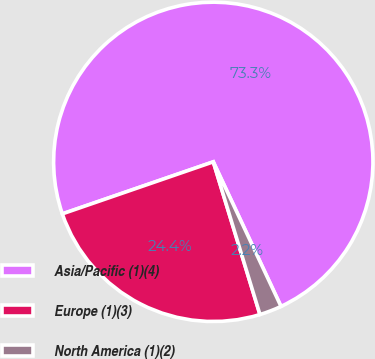<chart> <loc_0><loc_0><loc_500><loc_500><pie_chart><fcel>Asia/Pacific (1)(4)<fcel>Europe (1)(3)<fcel>North America (1)(2)<nl><fcel>73.31%<fcel>24.44%<fcel>2.25%<nl></chart> 